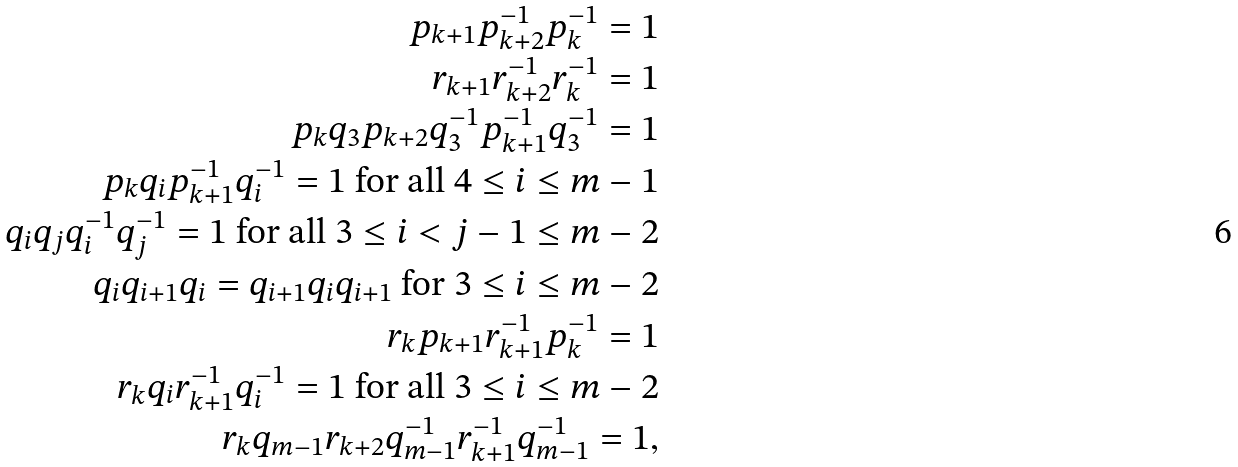<formula> <loc_0><loc_0><loc_500><loc_500>p _ { k + 1 } p _ { k + 2 } ^ { - 1 } p _ { k } ^ { - 1 } = 1 \\ r _ { k + 1 } r _ { k + 2 } ^ { - 1 } r _ { k } ^ { - 1 } = 1 \\ p _ { k } q _ { 3 } p _ { k + 2 } q _ { 3 } ^ { - 1 } p _ { k + 1 } ^ { - 1 } q _ { 3 } ^ { - 1 } = 1 \\ \text {$p_{k} q_{i} p_{k+1}^{-1} q_{i}^{-1}=1$ for all $4\leq i\leq m-1$} \\ \text {$q_{i}q_{j}q_{i}^{-1}q_{j}^{-1}=1$ for all $3\leq i<j-1\leq m-2$} \\ \text {$q_{i}q_{i+1}q_{i}=q_{i+1}q_{i}q_{i+1}$ for $3\leq i\leq m-2$} \\ r _ { k } p _ { k + 1 } r _ { k + 1 } ^ { - 1 } p _ { k } ^ { - 1 } = 1 \\ \text {$r_{k} q_{i} r_{k+1}^{-1} q_{i}^{-1}=1$ for all $3\leq i\leq m-2$} \\ r _ { k } q _ { m - 1 } r _ { k + 2 } q _ { m - 1 } ^ { - 1 } r _ { k + 1 } ^ { - 1 } q _ { m - 1 } ^ { - 1 } = 1 ,</formula> 